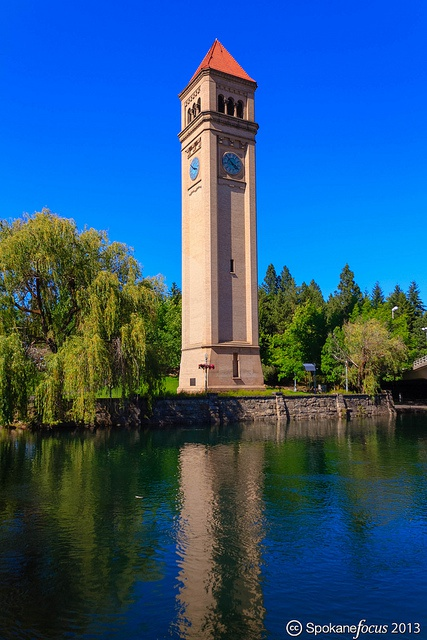Describe the objects in this image and their specific colors. I can see clock in blue, navy, and darkblue tones and clock in blue, lightblue, darkgray, and tan tones in this image. 